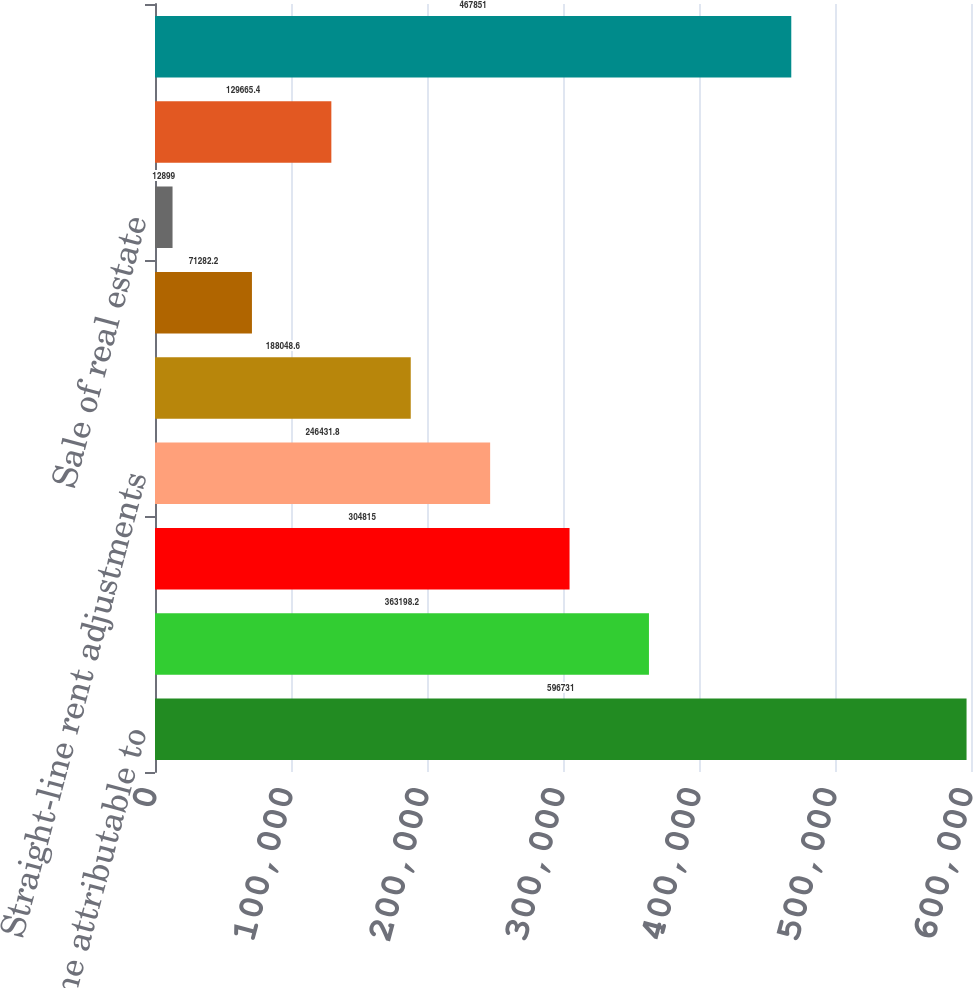Convert chart to OTSL. <chart><loc_0><loc_0><loc_500><loc_500><bar_chart><fcel>Net income attributable to<fcel>Depreciation and amortization<fcel>Mezzanine loans receivable<fcel>Straight-line rent adjustments<fcel>Earnings of partially owned<fcel>Stock options<fcel>Sale of real estate<fcel>Other net<fcel>Estimable taxable income<nl><fcel>596731<fcel>363198<fcel>304815<fcel>246432<fcel>188049<fcel>71282.2<fcel>12899<fcel>129665<fcel>467851<nl></chart> 